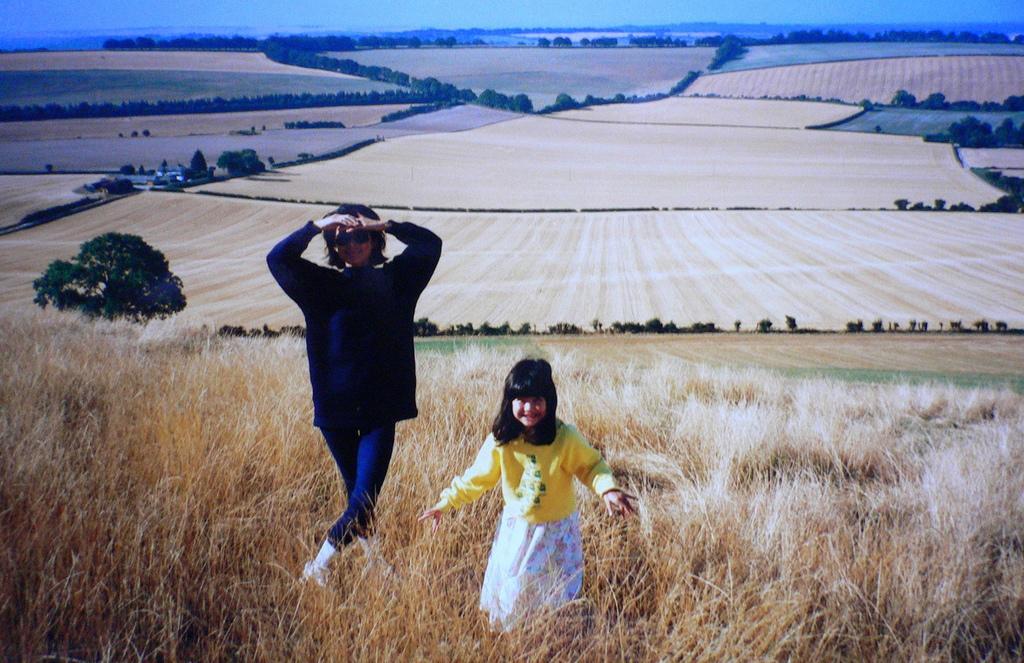Please provide a concise description of this image. In this picture there are girls on the left side of the image and there is greenery in the image, there are fields in the image. 